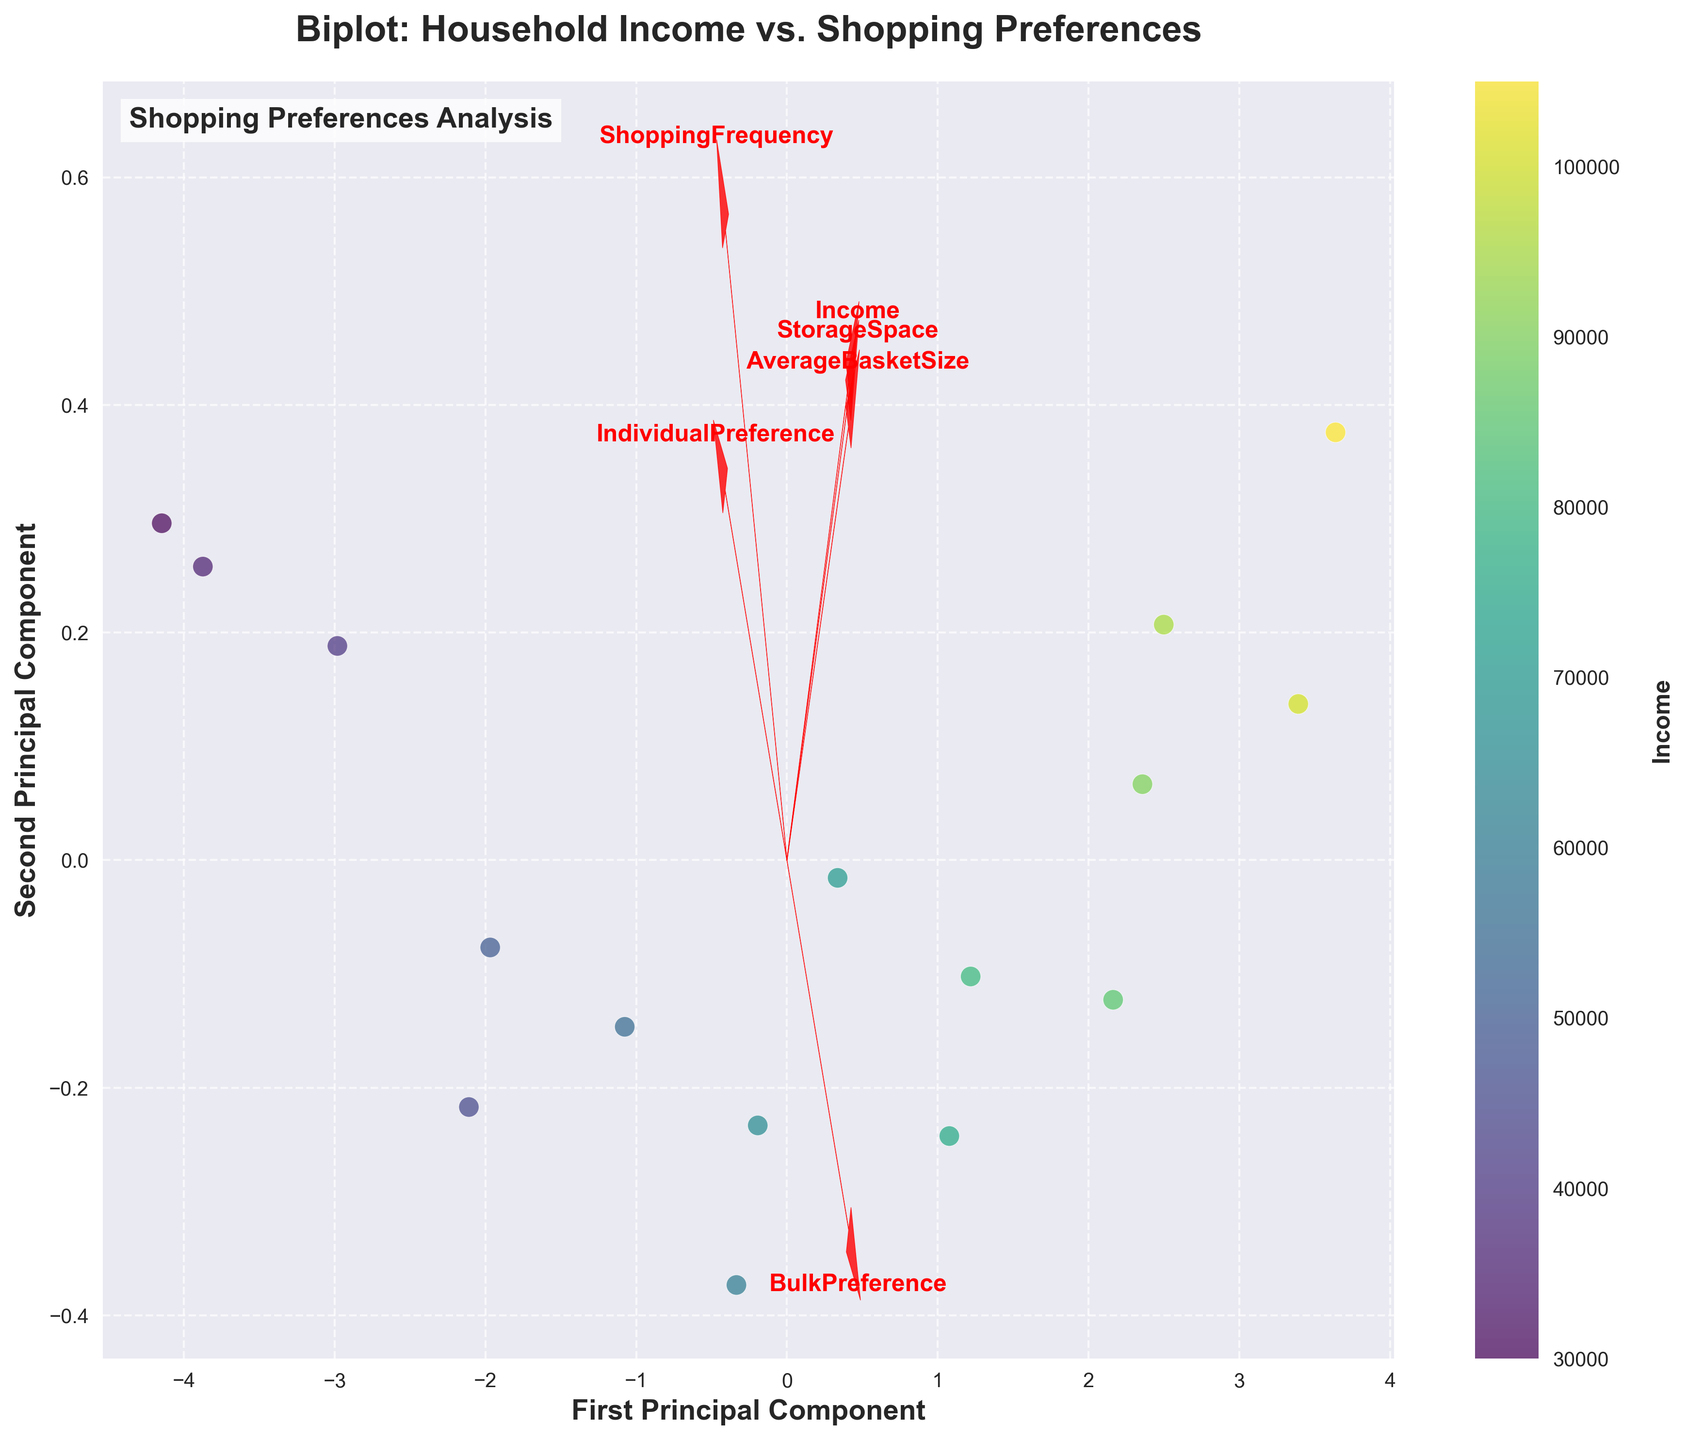What does the color gradient on the data points represent? The color gradient on the data points indicates the household income associated with each data point, with varying shades representing different income levels.
Answer: Household income What are the axes of the plot labeled as? The x-axis is labeled 'First Principal Component' and the y-axis is labeled 'Second Principal Component.' These labels indicate the principal components derived from PCA.
Answer: First Principal Component, Second Principal Component What's the general trend of the 'BulkPreference' vector in relation to the principal components? The 'BulkPreference' vector points positively along both the first and second principal components, indicating a positive relationship with both components.
Answer: Positive along both components How does 'ShoppingFrequency' correlate with the principal components? The 'ShoppingFrequency' vector points negatively along both the first and second principal components, indicating it has a negative correlation with both principal components.
Answer: Negatively correlated Which feature is most strongly aligned with the first principal component? The 'Income' vector is most strongly aligned with the first principal component, suggesting income is the primary driver of variance in the first principal component.
Answer: Income How can you tell which features are most important in explaining variance in the data? Features that have longer vectors and larger projections on the principal components are more important. In this plot, 'Income' and 'AverageBasketSize' have long vectors, indicating they are significant.
Answer: Look for longer vectors What does the 'AverageBasketSize' vector indicate about shopping behavior? The 'AverageBasketSize' vector points positively along the first principal component and negatively along the second, indicating that larger basket sizes are associated with higher income and opposite to frequent shopping.
Answer: Larger basket sizes with higher income, less frequent shopping What is the general trend of the data points concerning income? Data points representing higher income levels are more spread out along the first principal component, showing that income levels explain much of the variance along this axis.
Answer: Higher spread along the first principal component Is there a negative relationship between 'IndividualPreference' and 'BulkPreference' based on the vectors? Yes, the vectors for 'IndividualPreference' and 'BulkPreference' point in roughly opposite directions, indicating a negative relationship.
Answer: Negative relationship Which two features are closest in their directional trends? 'BulkPreference' and 'StorageSpace' are closest in their directional trends as their vectors point in similar directions.
Answer: BulkPreference and StorageSpace 